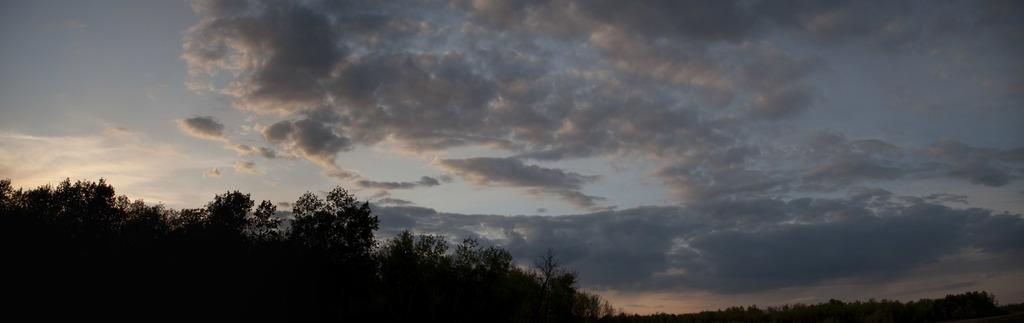What type of vegetation is visible in the front of the image? There are trees in the front of the image. What can be seen in the background of the image? There are clouds and the sky visible in the background of the image. How many ants can be seen climbing the trees in the image? There are no ants visible in the image; it only features trees. What type of vegetable is present in the image? There is no vegetable, such as celery, present in the image. 